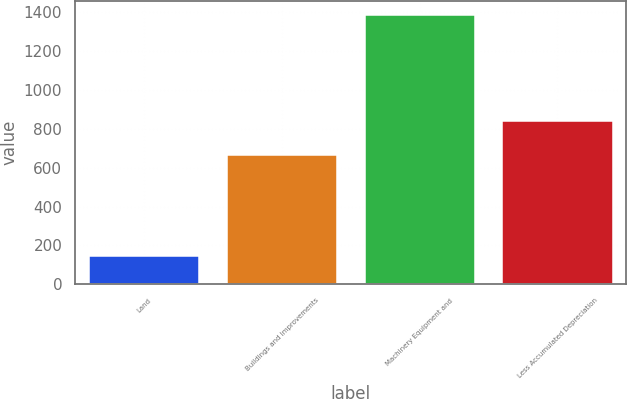Convert chart to OTSL. <chart><loc_0><loc_0><loc_500><loc_500><bar_chart><fcel>Land<fcel>Buildings and Improvements<fcel>Machinery Equipment and<fcel>Less Accumulated Depreciation<nl><fcel>142.9<fcel>667.4<fcel>1388.9<fcel>839<nl></chart> 